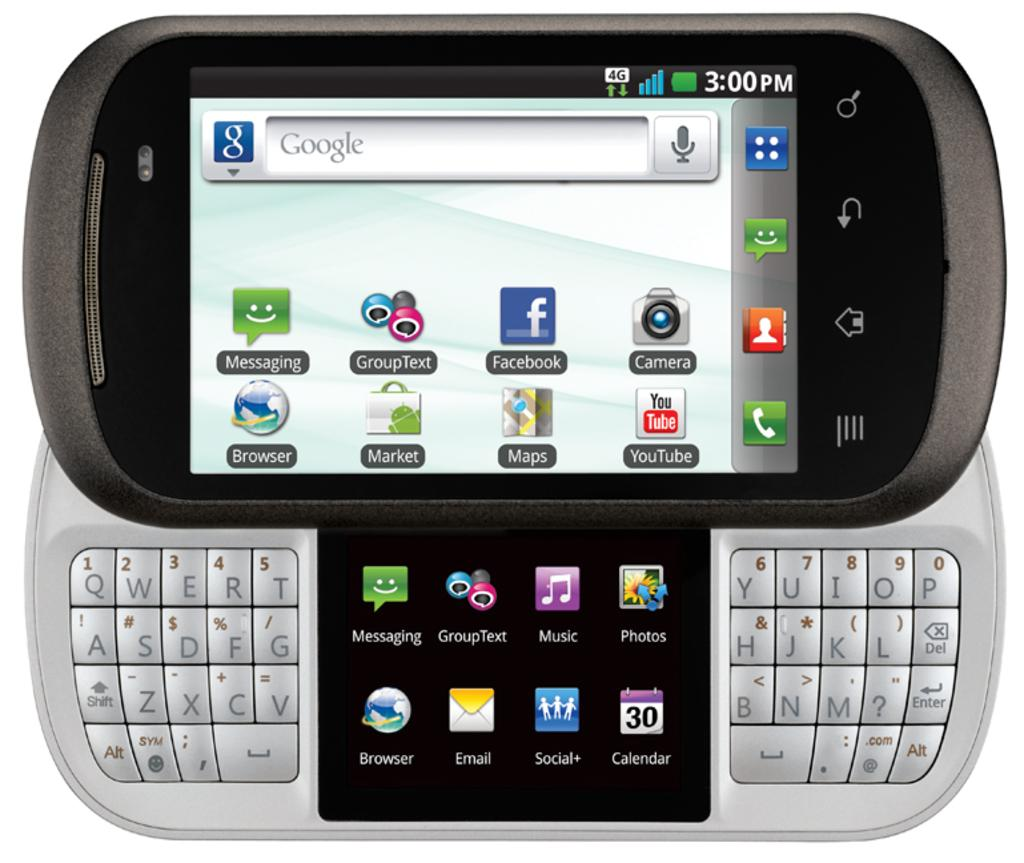<image>
Describe the image concisely. An open electriic device which is showing the word google at the top left. 